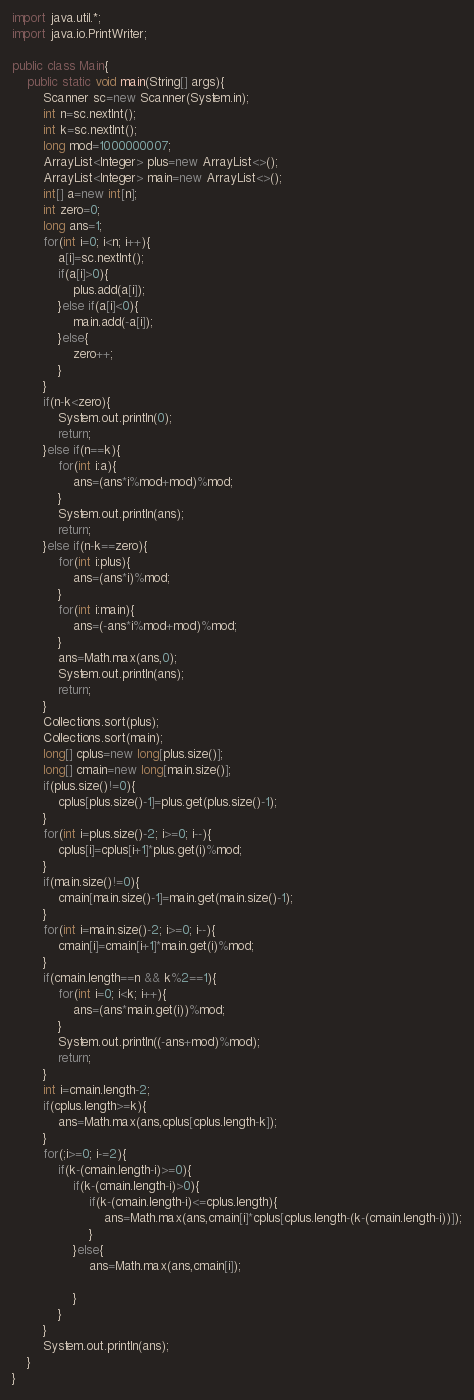Convert code to text. <code><loc_0><loc_0><loc_500><loc_500><_Java_>import java.util.*;
import java.io.PrintWriter;

public class Main{
	public static void main(String[] args){
		Scanner sc=new Scanner(System.in);
		int n=sc.nextInt();
		int k=sc.nextInt();
		long mod=1000000007;
		ArrayList<Integer> plus=new ArrayList<>();
		ArrayList<Integer> main=new ArrayList<>();
		int[] a=new int[n];
		int zero=0;
		long ans=1;
		for(int i=0; i<n; i++){
			a[i]=sc.nextInt();
			if(a[i]>0){
				plus.add(a[i]);
			}else if(a[i]<0){
				main.add(-a[i]);
			}else{
				zero++;
			}
		}
		if(n-k<zero){
			System.out.println(0);
			return;
		}else if(n==k){
			for(int i:a){
				ans=(ans*i%mod+mod)%mod;
			}
			System.out.println(ans);
			return;
		}else if(n-k==zero){
			for(int i:plus){
				ans=(ans*i)%mod;
			}
			for(int i:main){
				ans=(-ans*i%mod+mod)%mod;
			}
			ans=Math.max(ans,0);
			System.out.println(ans);
			return;
		}
		Collections.sort(plus);
		Collections.sort(main);
		long[] cplus=new long[plus.size()];
		long[] cmain=new long[main.size()];
		if(plus.size()!=0){
			cplus[plus.size()-1]=plus.get(plus.size()-1);
		}
		for(int i=plus.size()-2; i>=0; i--){
			cplus[i]=cplus[i+1]*plus.get(i)%mod;
		}
		if(main.size()!=0){
			cmain[main.size()-1]=main.get(main.size()-1);
		}
		for(int i=main.size()-2; i>=0; i--){
			cmain[i]=cmain[i+1]*main.get(i)%mod;
		}
		if(cmain.length==n && k%2==1){
			for(int i=0; i<k; i++){
				ans=(ans*main.get(i))%mod;
			}
			System.out.println((-ans+mod)%mod);
			return;
		}
		int i=cmain.length-2;
		if(cplus.length>=k){
			ans=Math.max(ans,cplus[cplus.length-k]);
		}
		for(;i>=0; i-=2){
			if(k-(cmain.length-i)>=0){
				if(k-(cmain.length-i)>0){
					if(k-(cmain.length-i)<=cplus.length){
						ans=Math.max(ans,cmain[i]*cplus[cplus.length-(k-(cmain.length-i))]);
					}
				}else{
					ans=Math.max(ans,cmain[i]);
				
				}
			}
		}
		System.out.println(ans);
	}
}
</code> 